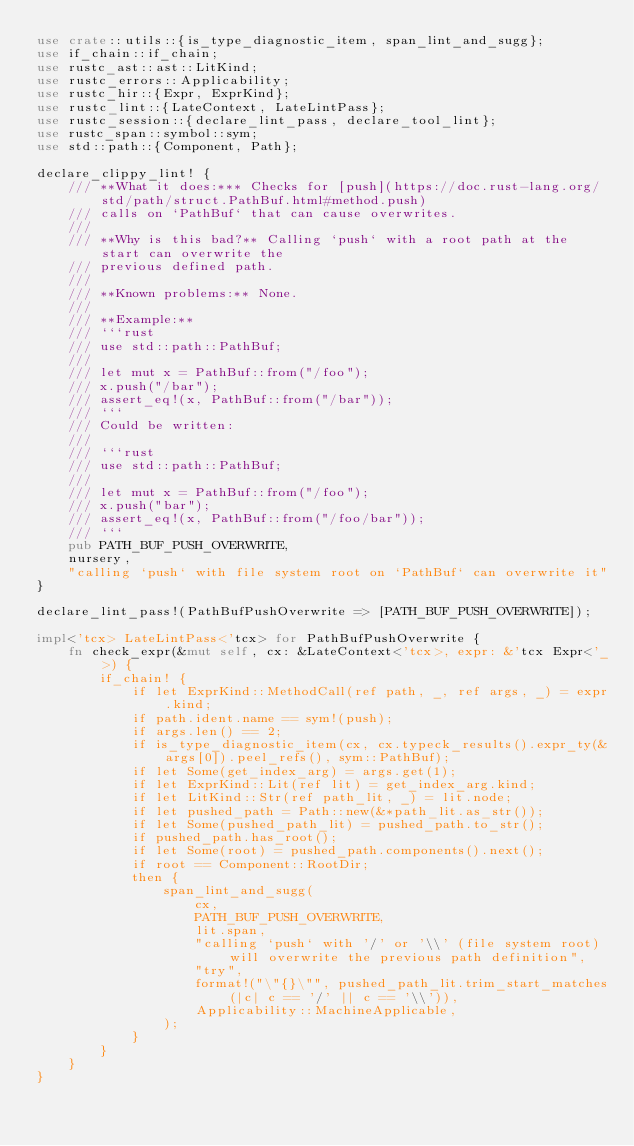<code> <loc_0><loc_0><loc_500><loc_500><_Rust_>use crate::utils::{is_type_diagnostic_item, span_lint_and_sugg};
use if_chain::if_chain;
use rustc_ast::ast::LitKind;
use rustc_errors::Applicability;
use rustc_hir::{Expr, ExprKind};
use rustc_lint::{LateContext, LateLintPass};
use rustc_session::{declare_lint_pass, declare_tool_lint};
use rustc_span::symbol::sym;
use std::path::{Component, Path};

declare_clippy_lint! {
    /// **What it does:*** Checks for [push](https://doc.rust-lang.org/std/path/struct.PathBuf.html#method.push)
    /// calls on `PathBuf` that can cause overwrites.
    ///
    /// **Why is this bad?** Calling `push` with a root path at the start can overwrite the
    /// previous defined path.
    ///
    /// **Known problems:** None.
    ///
    /// **Example:**
    /// ```rust
    /// use std::path::PathBuf;
    ///
    /// let mut x = PathBuf::from("/foo");
    /// x.push("/bar");
    /// assert_eq!(x, PathBuf::from("/bar"));
    /// ```
    /// Could be written:
    ///
    /// ```rust
    /// use std::path::PathBuf;
    ///
    /// let mut x = PathBuf::from("/foo");
    /// x.push("bar");
    /// assert_eq!(x, PathBuf::from("/foo/bar"));
    /// ```
    pub PATH_BUF_PUSH_OVERWRITE,
    nursery,
    "calling `push` with file system root on `PathBuf` can overwrite it"
}

declare_lint_pass!(PathBufPushOverwrite => [PATH_BUF_PUSH_OVERWRITE]);

impl<'tcx> LateLintPass<'tcx> for PathBufPushOverwrite {
    fn check_expr(&mut self, cx: &LateContext<'tcx>, expr: &'tcx Expr<'_>) {
        if_chain! {
            if let ExprKind::MethodCall(ref path, _, ref args, _) = expr.kind;
            if path.ident.name == sym!(push);
            if args.len() == 2;
            if is_type_diagnostic_item(cx, cx.typeck_results().expr_ty(&args[0]).peel_refs(), sym::PathBuf);
            if let Some(get_index_arg) = args.get(1);
            if let ExprKind::Lit(ref lit) = get_index_arg.kind;
            if let LitKind::Str(ref path_lit, _) = lit.node;
            if let pushed_path = Path::new(&*path_lit.as_str());
            if let Some(pushed_path_lit) = pushed_path.to_str();
            if pushed_path.has_root();
            if let Some(root) = pushed_path.components().next();
            if root == Component::RootDir;
            then {
                span_lint_and_sugg(
                    cx,
                    PATH_BUF_PUSH_OVERWRITE,
                    lit.span,
                    "calling `push` with '/' or '\\' (file system root) will overwrite the previous path definition",
                    "try",
                    format!("\"{}\"", pushed_path_lit.trim_start_matches(|c| c == '/' || c == '\\')),
                    Applicability::MachineApplicable,
                );
            }
        }
    }
}
</code> 